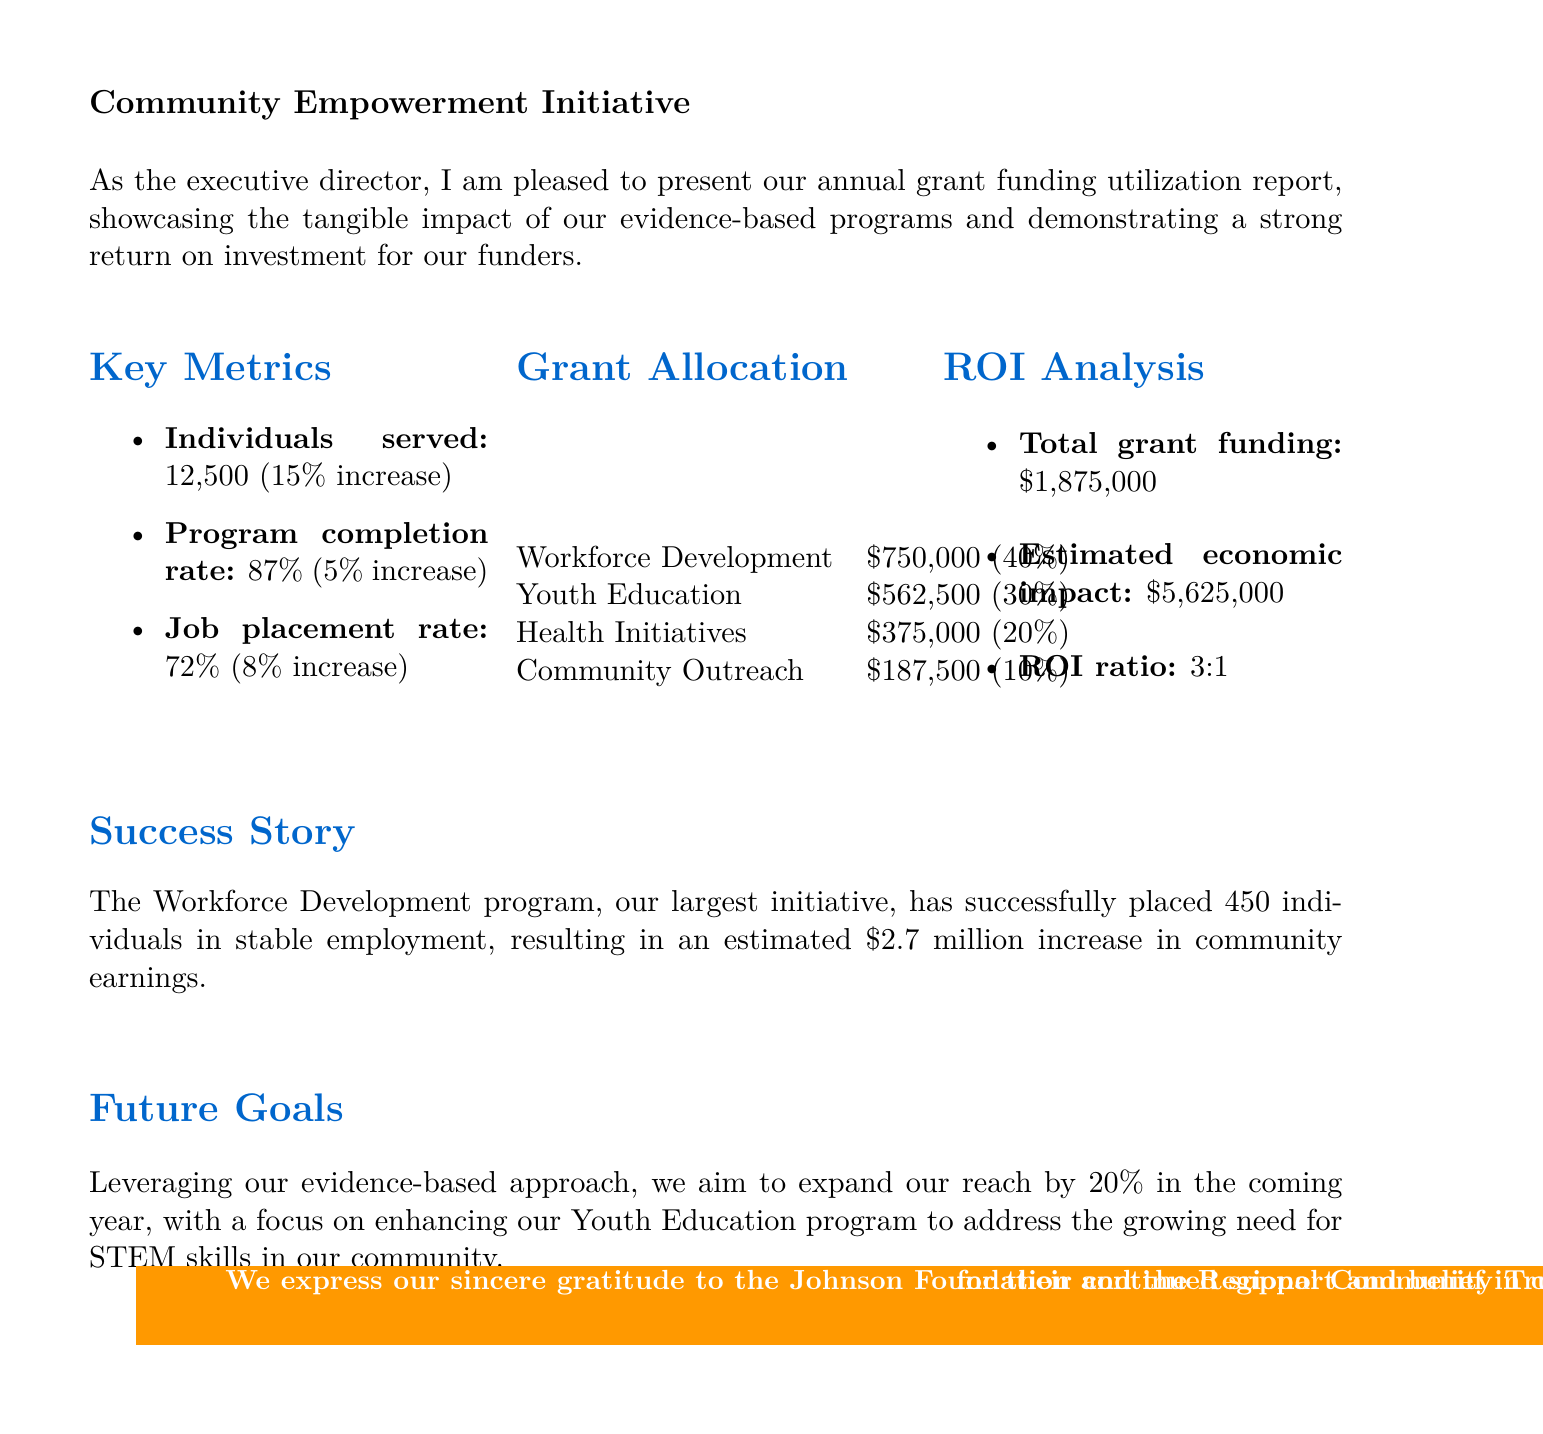what is the total number of individuals served? The total number of individuals served is stated clearly in the key metrics section of the report.
Answer: 12,500 what was the job placement rate? The job placement rate is provided in the key metrics section, indicating the percentage of individuals placed in jobs.
Answer: 72% what is the estimated economic impact? The estimated economic impact reflects the financial benefits generated from the grant funding, as noted in the ROI analysis.
Answer: $5,625,000 which program received the largest allocation of grant funding? The grant allocation section reveals the distribution of funds among programs, indicating which one received the most.
Answer: Workforce Development by what percentage did the program completion rate increase from the previous year? The increase in program completion rate is mentioned in the key metrics section, showing the progress made compared to last year.
Answer: 5% what is the return on investment ratio? The ROI analysis section provides a clear metric for understanding the return for every dollar invested in grant funding.
Answer: 3:1 how much funding was allocated to Health Initiatives? The grant allocation section explicitly states the amount designated for each program, including Health Initiatives.
Answer: $375,000 what is a future goal set by the organization? The future goals section outlines the strategic objectives the organization aims to achieve in the coming year, based on the report.
Answer: Expand reach by 20% what successful outcome is highlighted in the success story? The success story section emphasizes a specific achievement from one of the programs, showcasing its impact.
Answer: Placed 450 individuals in stable employment 